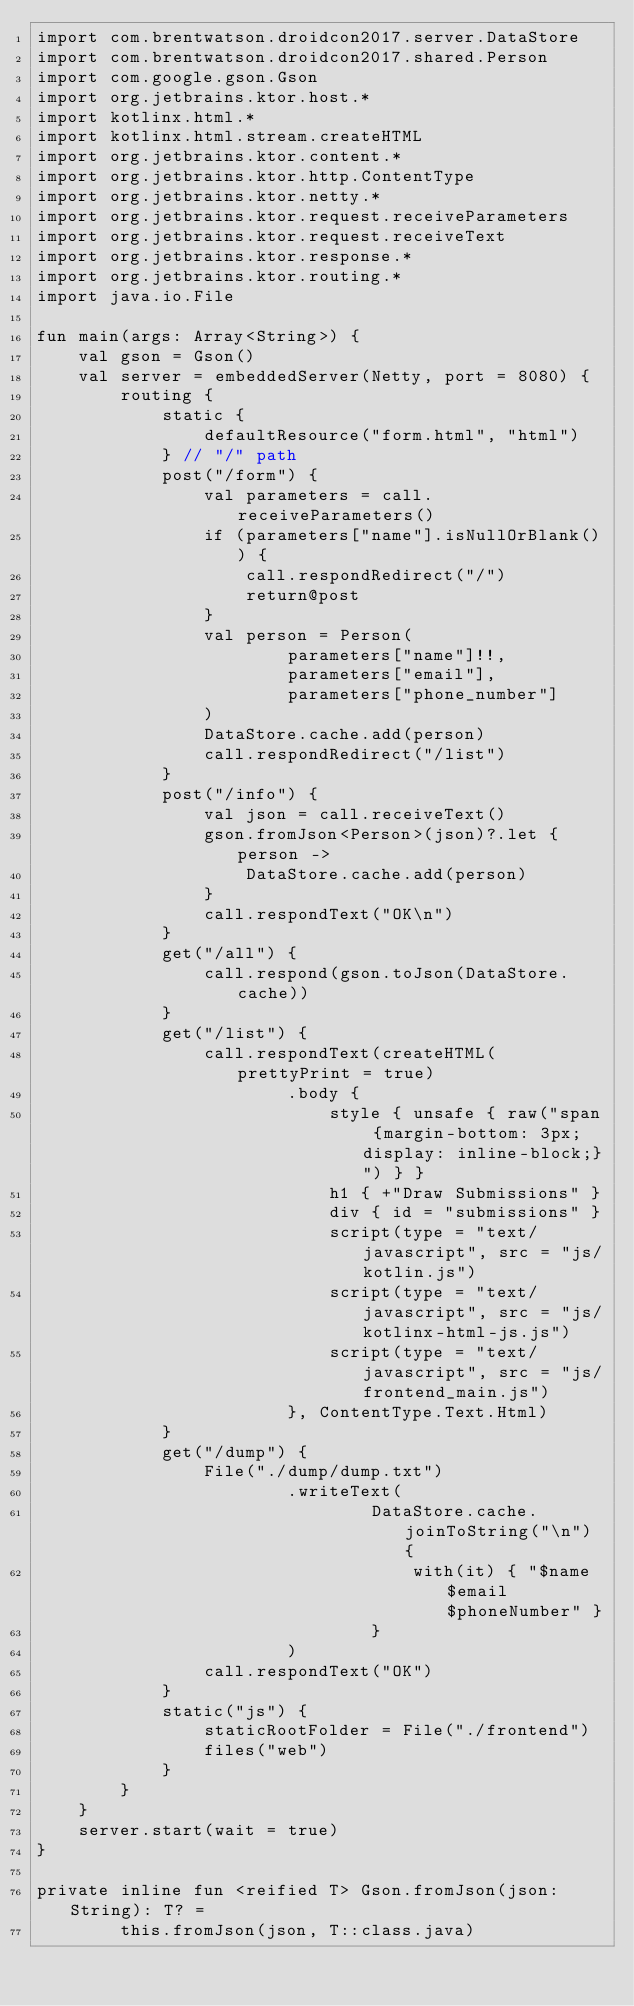Convert code to text. <code><loc_0><loc_0><loc_500><loc_500><_Kotlin_>import com.brentwatson.droidcon2017.server.DataStore
import com.brentwatson.droidcon2017.shared.Person
import com.google.gson.Gson
import org.jetbrains.ktor.host.*
import kotlinx.html.*
import kotlinx.html.stream.createHTML
import org.jetbrains.ktor.content.*
import org.jetbrains.ktor.http.ContentType
import org.jetbrains.ktor.netty.*
import org.jetbrains.ktor.request.receiveParameters
import org.jetbrains.ktor.request.receiveText
import org.jetbrains.ktor.response.*
import org.jetbrains.ktor.routing.*
import java.io.File

fun main(args: Array<String>) {
    val gson = Gson()
    val server = embeddedServer(Netty, port = 8080) {
        routing {
            static {
                defaultResource("form.html", "html")
            } // "/" path
            post("/form") {
                val parameters = call.receiveParameters()
                if (parameters["name"].isNullOrBlank()) {
                    call.respondRedirect("/")
                    return@post
                }
                val person = Person(
                        parameters["name"]!!,
                        parameters["email"],
                        parameters["phone_number"]
                )
                DataStore.cache.add(person)
                call.respondRedirect("/list")
            }
            post("/info") {
                val json = call.receiveText()
                gson.fromJson<Person>(json)?.let { person ->
                    DataStore.cache.add(person)
                }
                call.respondText("OK\n")
            }
            get("/all") {
                call.respond(gson.toJson(DataStore.cache))
            }
            get("/list") {
                call.respondText(createHTML(prettyPrint = true)
                        .body {
                            style { unsafe { raw("span {margin-bottom: 3px; display: inline-block;}") } }
                            h1 { +"Draw Submissions" }
                            div { id = "submissions" }
                            script(type = "text/javascript", src = "js/kotlin.js")
                            script(type = "text/javascript", src = "js/kotlinx-html-js.js")
                            script(type = "text/javascript", src = "js/frontend_main.js")
                        }, ContentType.Text.Html)
            }
            get("/dump") {
                File("./dump/dump.txt")
                        .writeText(
                                DataStore.cache.joinToString("\n") {
                                    with(it) { "$name $email $phoneNumber" }
                                }
                        )
                call.respondText("OK")
            }
            static("js") {
                staticRootFolder = File("./frontend")
                files("web")
            }
        }
    }
    server.start(wait = true)
}

private inline fun <reified T> Gson.fromJson(json: String): T? =
        this.fromJson(json, T::class.java)
</code> 